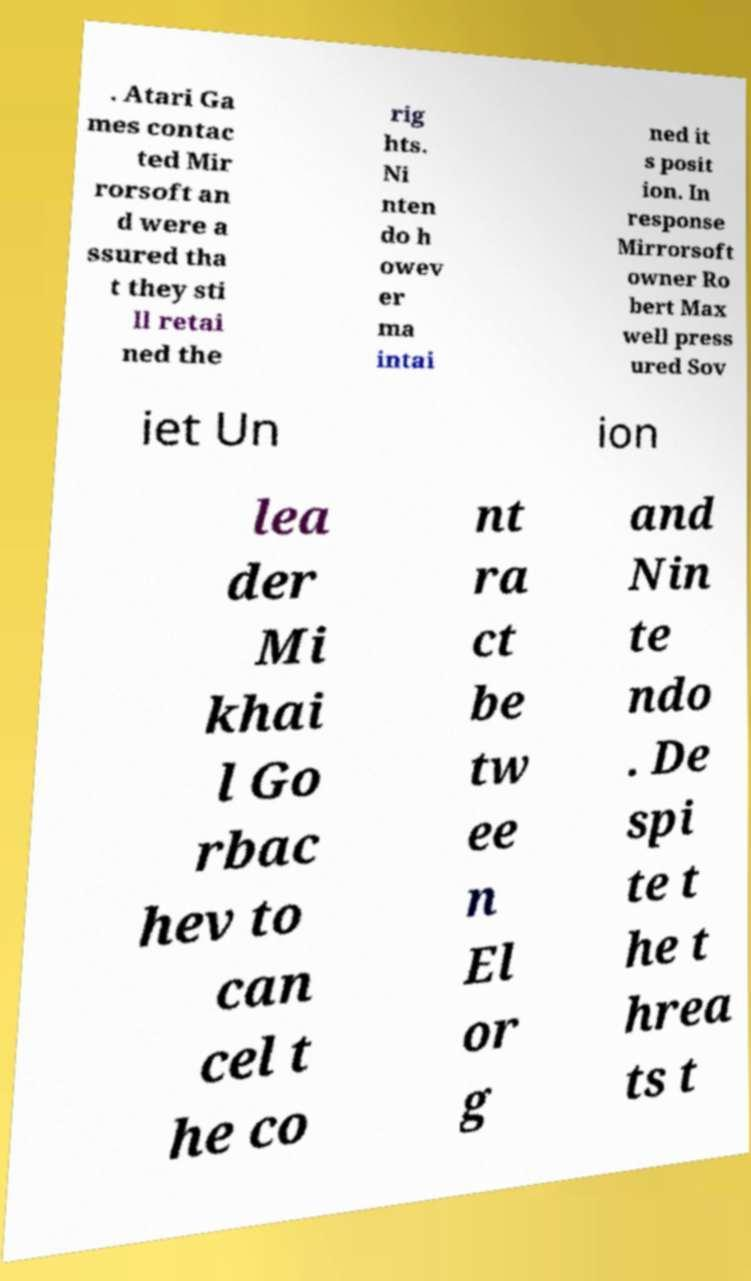Can you accurately transcribe the text from the provided image for me? . Atari Ga mes contac ted Mir rorsoft an d were a ssured tha t they sti ll retai ned the rig hts. Ni nten do h owev er ma intai ned it s posit ion. In response Mirrorsoft owner Ro bert Max well press ured Sov iet Un ion lea der Mi khai l Go rbac hev to can cel t he co nt ra ct be tw ee n El or g and Nin te ndo . De spi te t he t hrea ts t 